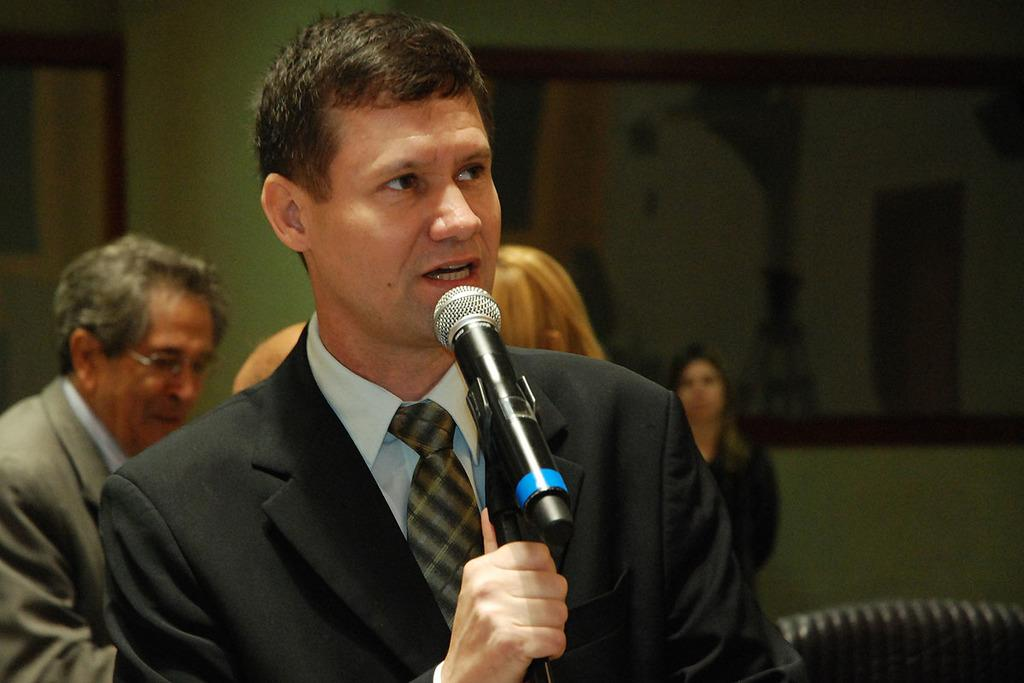What is the man in the image holding? The man is holding a mic. What is the man wearing in the image? The man is wearing a suit. Can you describe the background of the image? There are people in the background of the image. What type of whip is the man using to control the crowd in the image? There is no whip present in the image; the man is holding a mic. What is the man using to carry water in the image? There is no pail or any indication of carrying water in the image. 